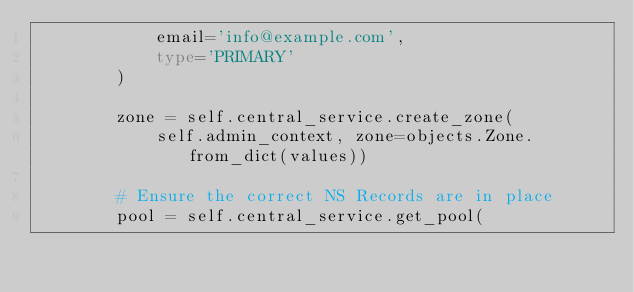<code> <loc_0><loc_0><loc_500><loc_500><_Python_>            email='info@example.com',
            type='PRIMARY'
        )

        zone = self.central_service.create_zone(
            self.admin_context, zone=objects.Zone.from_dict(values))

        # Ensure the correct NS Records are in place
        pool = self.central_service.get_pool(</code> 